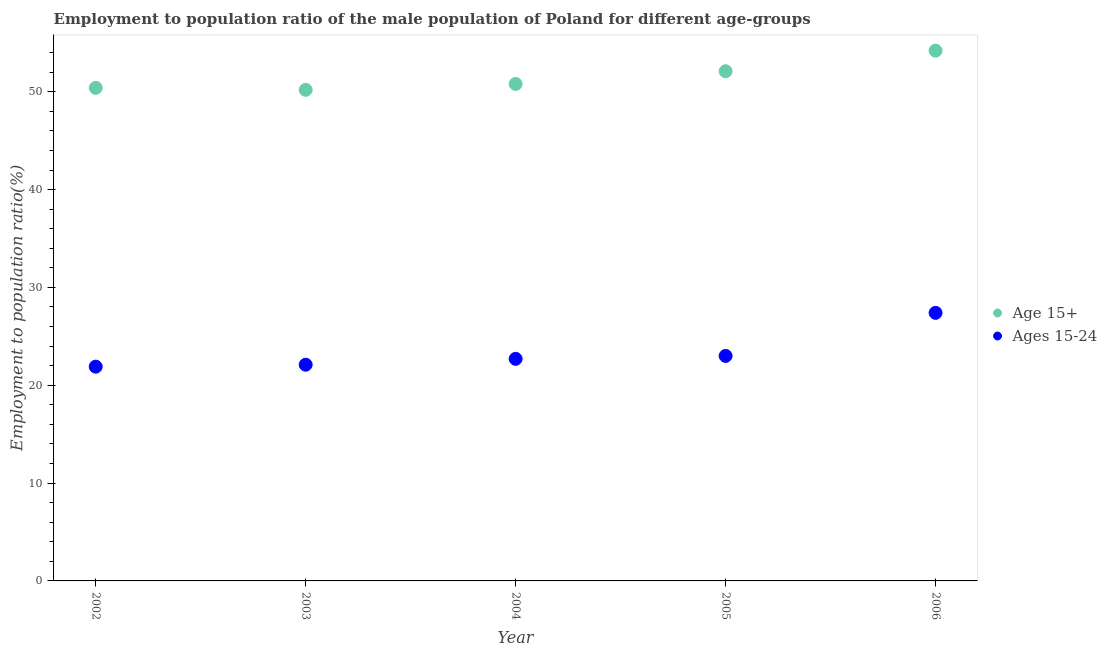Is the number of dotlines equal to the number of legend labels?
Offer a very short reply. Yes. What is the employment to population ratio(age 15-24) in 2003?
Offer a terse response. 22.1. Across all years, what is the maximum employment to population ratio(age 15+)?
Offer a terse response. 54.2. Across all years, what is the minimum employment to population ratio(age 15+)?
Ensure brevity in your answer.  50.2. In which year was the employment to population ratio(age 15-24) maximum?
Make the answer very short. 2006. In which year was the employment to population ratio(age 15+) minimum?
Your answer should be very brief. 2003. What is the total employment to population ratio(age 15+) in the graph?
Offer a terse response. 257.7. What is the difference between the employment to population ratio(age 15-24) in 2002 and that in 2005?
Keep it short and to the point. -1.1. What is the difference between the employment to population ratio(age 15-24) in 2003 and the employment to population ratio(age 15+) in 2004?
Keep it short and to the point. -28.7. What is the average employment to population ratio(age 15+) per year?
Give a very brief answer. 51.54. In the year 2003, what is the difference between the employment to population ratio(age 15-24) and employment to population ratio(age 15+)?
Keep it short and to the point. -28.1. In how many years, is the employment to population ratio(age 15+) greater than 20 %?
Provide a succinct answer. 5. What is the ratio of the employment to population ratio(age 15+) in 2002 to that in 2006?
Your answer should be compact. 0.93. Is the employment to population ratio(age 15+) in 2002 less than that in 2006?
Provide a succinct answer. Yes. Is the difference between the employment to population ratio(age 15+) in 2002 and 2006 greater than the difference between the employment to population ratio(age 15-24) in 2002 and 2006?
Offer a very short reply. Yes. What is the difference between the highest and the second highest employment to population ratio(age 15-24)?
Offer a very short reply. 4.4. What is the difference between the highest and the lowest employment to population ratio(age 15-24)?
Offer a terse response. 5.5. In how many years, is the employment to population ratio(age 15+) greater than the average employment to population ratio(age 15+) taken over all years?
Give a very brief answer. 2. Is the sum of the employment to population ratio(age 15+) in 2003 and 2006 greater than the maximum employment to population ratio(age 15-24) across all years?
Provide a succinct answer. Yes. Is the employment to population ratio(age 15+) strictly greater than the employment to population ratio(age 15-24) over the years?
Provide a succinct answer. Yes. Is the employment to population ratio(age 15-24) strictly less than the employment to population ratio(age 15+) over the years?
Offer a terse response. Yes. How many dotlines are there?
Offer a terse response. 2. How many years are there in the graph?
Offer a very short reply. 5. Are the values on the major ticks of Y-axis written in scientific E-notation?
Provide a short and direct response. No. Does the graph contain grids?
Make the answer very short. No. How many legend labels are there?
Your answer should be compact. 2. How are the legend labels stacked?
Provide a short and direct response. Vertical. What is the title of the graph?
Give a very brief answer. Employment to population ratio of the male population of Poland for different age-groups. Does "Excluding technical cooperation" appear as one of the legend labels in the graph?
Provide a succinct answer. No. What is the Employment to population ratio(%) in Age 15+ in 2002?
Your response must be concise. 50.4. What is the Employment to population ratio(%) in Ages 15-24 in 2002?
Offer a terse response. 21.9. What is the Employment to population ratio(%) of Age 15+ in 2003?
Offer a very short reply. 50.2. What is the Employment to population ratio(%) in Ages 15-24 in 2003?
Give a very brief answer. 22.1. What is the Employment to population ratio(%) in Age 15+ in 2004?
Offer a very short reply. 50.8. What is the Employment to population ratio(%) of Ages 15-24 in 2004?
Give a very brief answer. 22.7. What is the Employment to population ratio(%) of Age 15+ in 2005?
Offer a terse response. 52.1. What is the Employment to population ratio(%) in Ages 15-24 in 2005?
Make the answer very short. 23. What is the Employment to population ratio(%) of Age 15+ in 2006?
Keep it short and to the point. 54.2. What is the Employment to population ratio(%) in Ages 15-24 in 2006?
Offer a very short reply. 27.4. Across all years, what is the maximum Employment to population ratio(%) in Age 15+?
Offer a very short reply. 54.2. Across all years, what is the maximum Employment to population ratio(%) in Ages 15-24?
Offer a very short reply. 27.4. Across all years, what is the minimum Employment to population ratio(%) in Age 15+?
Your answer should be compact. 50.2. Across all years, what is the minimum Employment to population ratio(%) of Ages 15-24?
Make the answer very short. 21.9. What is the total Employment to population ratio(%) of Age 15+ in the graph?
Your answer should be very brief. 257.7. What is the total Employment to population ratio(%) of Ages 15-24 in the graph?
Your answer should be compact. 117.1. What is the difference between the Employment to population ratio(%) of Age 15+ in 2002 and that in 2003?
Make the answer very short. 0.2. What is the difference between the Employment to population ratio(%) in Ages 15-24 in 2002 and that in 2004?
Provide a succinct answer. -0.8. What is the difference between the Employment to population ratio(%) of Age 15+ in 2002 and that in 2006?
Keep it short and to the point. -3.8. What is the difference between the Employment to population ratio(%) in Ages 15-24 in 2002 and that in 2006?
Provide a succinct answer. -5.5. What is the difference between the Employment to population ratio(%) in Age 15+ in 2003 and that in 2004?
Ensure brevity in your answer.  -0.6. What is the difference between the Employment to population ratio(%) in Ages 15-24 in 2003 and that in 2004?
Keep it short and to the point. -0.6. What is the difference between the Employment to population ratio(%) in Ages 15-24 in 2003 and that in 2005?
Offer a very short reply. -0.9. What is the difference between the Employment to population ratio(%) in Age 15+ in 2003 and that in 2006?
Your answer should be compact. -4. What is the difference between the Employment to population ratio(%) in Age 15+ in 2004 and that in 2005?
Your answer should be compact. -1.3. What is the difference between the Employment to population ratio(%) of Age 15+ in 2005 and that in 2006?
Keep it short and to the point. -2.1. What is the difference between the Employment to population ratio(%) in Age 15+ in 2002 and the Employment to population ratio(%) in Ages 15-24 in 2003?
Keep it short and to the point. 28.3. What is the difference between the Employment to population ratio(%) in Age 15+ in 2002 and the Employment to population ratio(%) in Ages 15-24 in 2004?
Your answer should be compact. 27.7. What is the difference between the Employment to population ratio(%) in Age 15+ in 2002 and the Employment to population ratio(%) in Ages 15-24 in 2005?
Give a very brief answer. 27.4. What is the difference between the Employment to population ratio(%) of Age 15+ in 2002 and the Employment to population ratio(%) of Ages 15-24 in 2006?
Your answer should be very brief. 23. What is the difference between the Employment to population ratio(%) in Age 15+ in 2003 and the Employment to population ratio(%) in Ages 15-24 in 2004?
Provide a short and direct response. 27.5. What is the difference between the Employment to population ratio(%) in Age 15+ in 2003 and the Employment to population ratio(%) in Ages 15-24 in 2005?
Your answer should be compact. 27.2. What is the difference between the Employment to population ratio(%) of Age 15+ in 2003 and the Employment to population ratio(%) of Ages 15-24 in 2006?
Your answer should be compact. 22.8. What is the difference between the Employment to population ratio(%) in Age 15+ in 2004 and the Employment to population ratio(%) in Ages 15-24 in 2005?
Your answer should be very brief. 27.8. What is the difference between the Employment to population ratio(%) in Age 15+ in 2004 and the Employment to population ratio(%) in Ages 15-24 in 2006?
Your answer should be compact. 23.4. What is the difference between the Employment to population ratio(%) of Age 15+ in 2005 and the Employment to population ratio(%) of Ages 15-24 in 2006?
Your response must be concise. 24.7. What is the average Employment to population ratio(%) of Age 15+ per year?
Ensure brevity in your answer.  51.54. What is the average Employment to population ratio(%) in Ages 15-24 per year?
Offer a terse response. 23.42. In the year 2002, what is the difference between the Employment to population ratio(%) in Age 15+ and Employment to population ratio(%) in Ages 15-24?
Keep it short and to the point. 28.5. In the year 2003, what is the difference between the Employment to population ratio(%) in Age 15+ and Employment to population ratio(%) in Ages 15-24?
Keep it short and to the point. 28.1. In the year 2004, what is the difference between the Employment to population ratio(%) in Age 15+ and Employment to population ratio(%) in Ages 15-24?
Offer a very short reply. 28.1. In the year 2005, what is the difference between the Employment to population ratio(%) in Age 15+ and Employment to population ratio(%) in Ages 15-24?
Your response must be concise. 29.1. In the year 2006, what is the difference between the Employment to population ratio(%) of Age 15+ and Employment to population ratio(%) of Ages 15-24?
Offer a terse response. 26.8. What is the ratio of the Employment to population ratio(%) of Ages 15-24 in 2002 to that in 2003?
Give a very brief answer. 0.99. What is the ratio of the Employment to population ratio(%) in Ages 15-24 in 2002 to that in 2004?
Provide a succinct answer. 0.96. What is the ratio of the Employment to population ratio(%) of Age 15+ in 2002 to that in 2005?
Your answer should be compact. 0.97. What is the ratio of the Employment to population ratio(%) in Ages 15-24 in 2002 to that in 2005?
Your answer should be compact. 0.95. What is the ratio of the Employment to population ratio(%) in Age 15+ in 2002 to that in 2006?
Give a very brief answer. 0.93. What is the ratio of the Employment to population ratio(%) of Ages 15-24 in 2002 to that in 2006?
Provide a succinct answer. 0.8. What is the ratio of the Employment to population ratio(%) in Age 15+ in 2003 to that in 2004?
Make the answer very short. 0.99. What is the ratio of the Employment to population ratio(%) of Ages 15-24 in 2003 to that in 2004?
Ensure brevity in your answer.  0.97. What is the ratio of the Employment to population ratio(%) of Age 15+ in 2003 to that in 2005?
Keep it short and to the point. 0.96. What is the ratio of the Employment to population ratio(%) of Ages 15-24 in 2003 to that in 2005?
Provide a short and direct response. 0.96. What is the ratio of the Employment to population ratio(%) of Age 15+ in 2003 to that in 2006?
Ensure brevity in your answer.  0.93. What is the ratio of the Employment to population ratio(%) in Ages 15-24 in 2003 to that in 2006?
Your answer should be compact. 0.81. What is the ratio of the Employment to population ratio(%) of Age 15+ in 2004 to that in 2005?
Give a very brief answer. 0.97. What is the ratio of the Employment to population ratio(%) of Ages 15-24 in 2004 to that in 2005?
Offer a very short reply. 0.99. What is the ratio of the Employment to population ratio(%) of Age 15+ in 2004 to that in 2006?
Ensure brevity in your answer.  0.94. What is the ratio of the Employment to population ratio(%) of Ages 15-24 in 2004 to that in 2006?
Ensure brevity in your answer.  0.83. What is the ratio of the Employment to population ratio(%) of Age 15+ in 2005 to that in 2006?
Give a very brief answer. 0.96. What is the ratio of the Employment to population ratio(%) in Ages 15-24 in 2005 to that in 2006?
Ensure brevity in your answer.  0.84. 